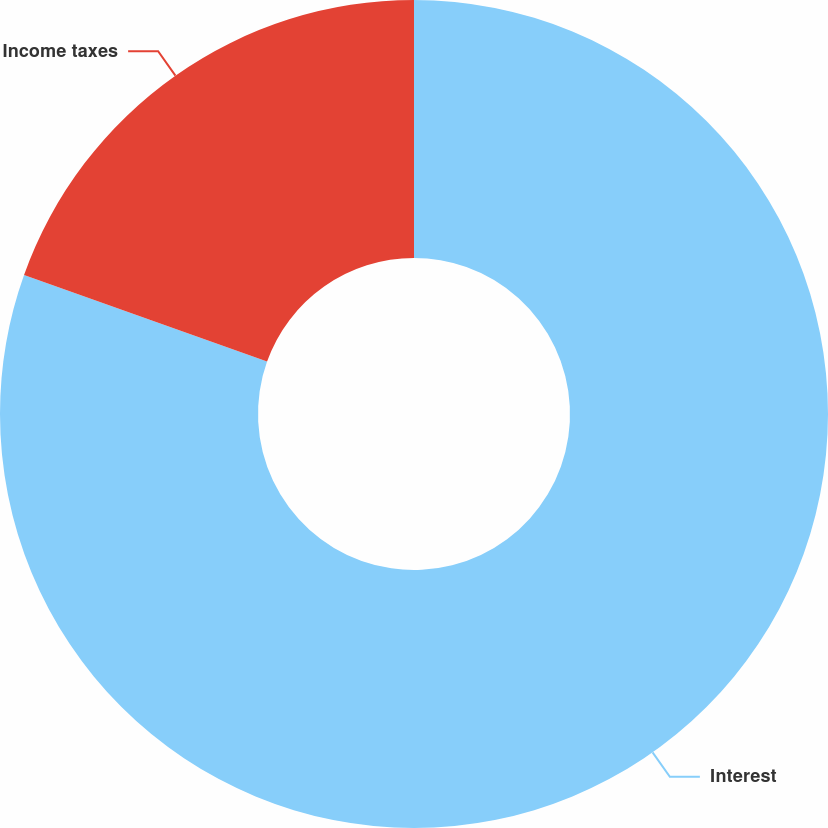<chart> <loc_0><loc_0><loc_500><loc_500><pie_chart><fcel>Interest<fcel>Income taxes<nl><fcel>80.45%<fcel>19.55%<nl></chart> 